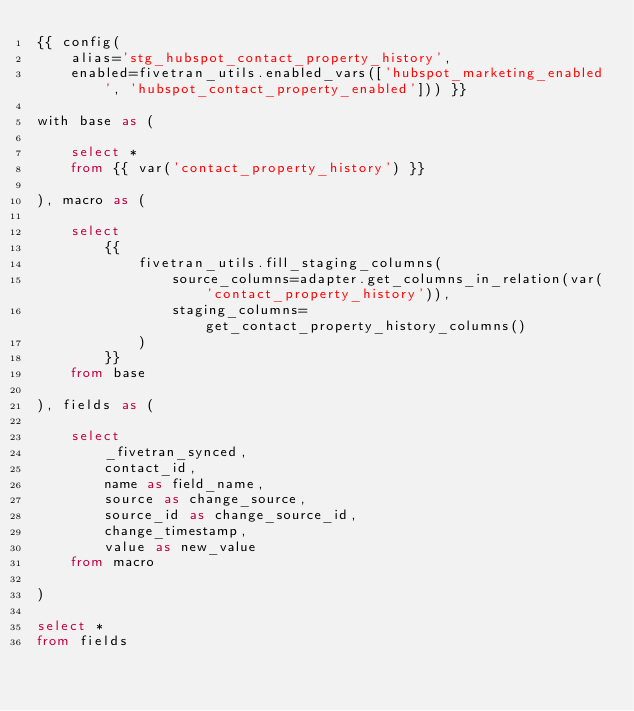<code> <loc_0><loc_0><loc_500><loc_500><_SQL_>{{ config(
    alias='stg_hubspot_contact_property_history',
    enabled=fivetran_utils.enabled_vars(['hubspot_marketing_enabled', 'hubspot_contact_property_enabled'])) }}

with base as (

    select *
    from {{ var('contact_property_history') }}

), macro as (

    select
        {{
            fivetran_utils.fill_staging_columns(
                source_columns=adapter.get_columns_in_relation(var('contact_property_history')),
                staging_columns=get_contact_property_history_columns()
            )
        }}
    from base

), fields as (

    select
        _fivetran_synced,
        contact_id,
        name as field_name,
        source as change_source,
        source_id as change_source_id,
        change_timestamp,
        value as new_value
    from macro

)

select *
from fields
</code> 